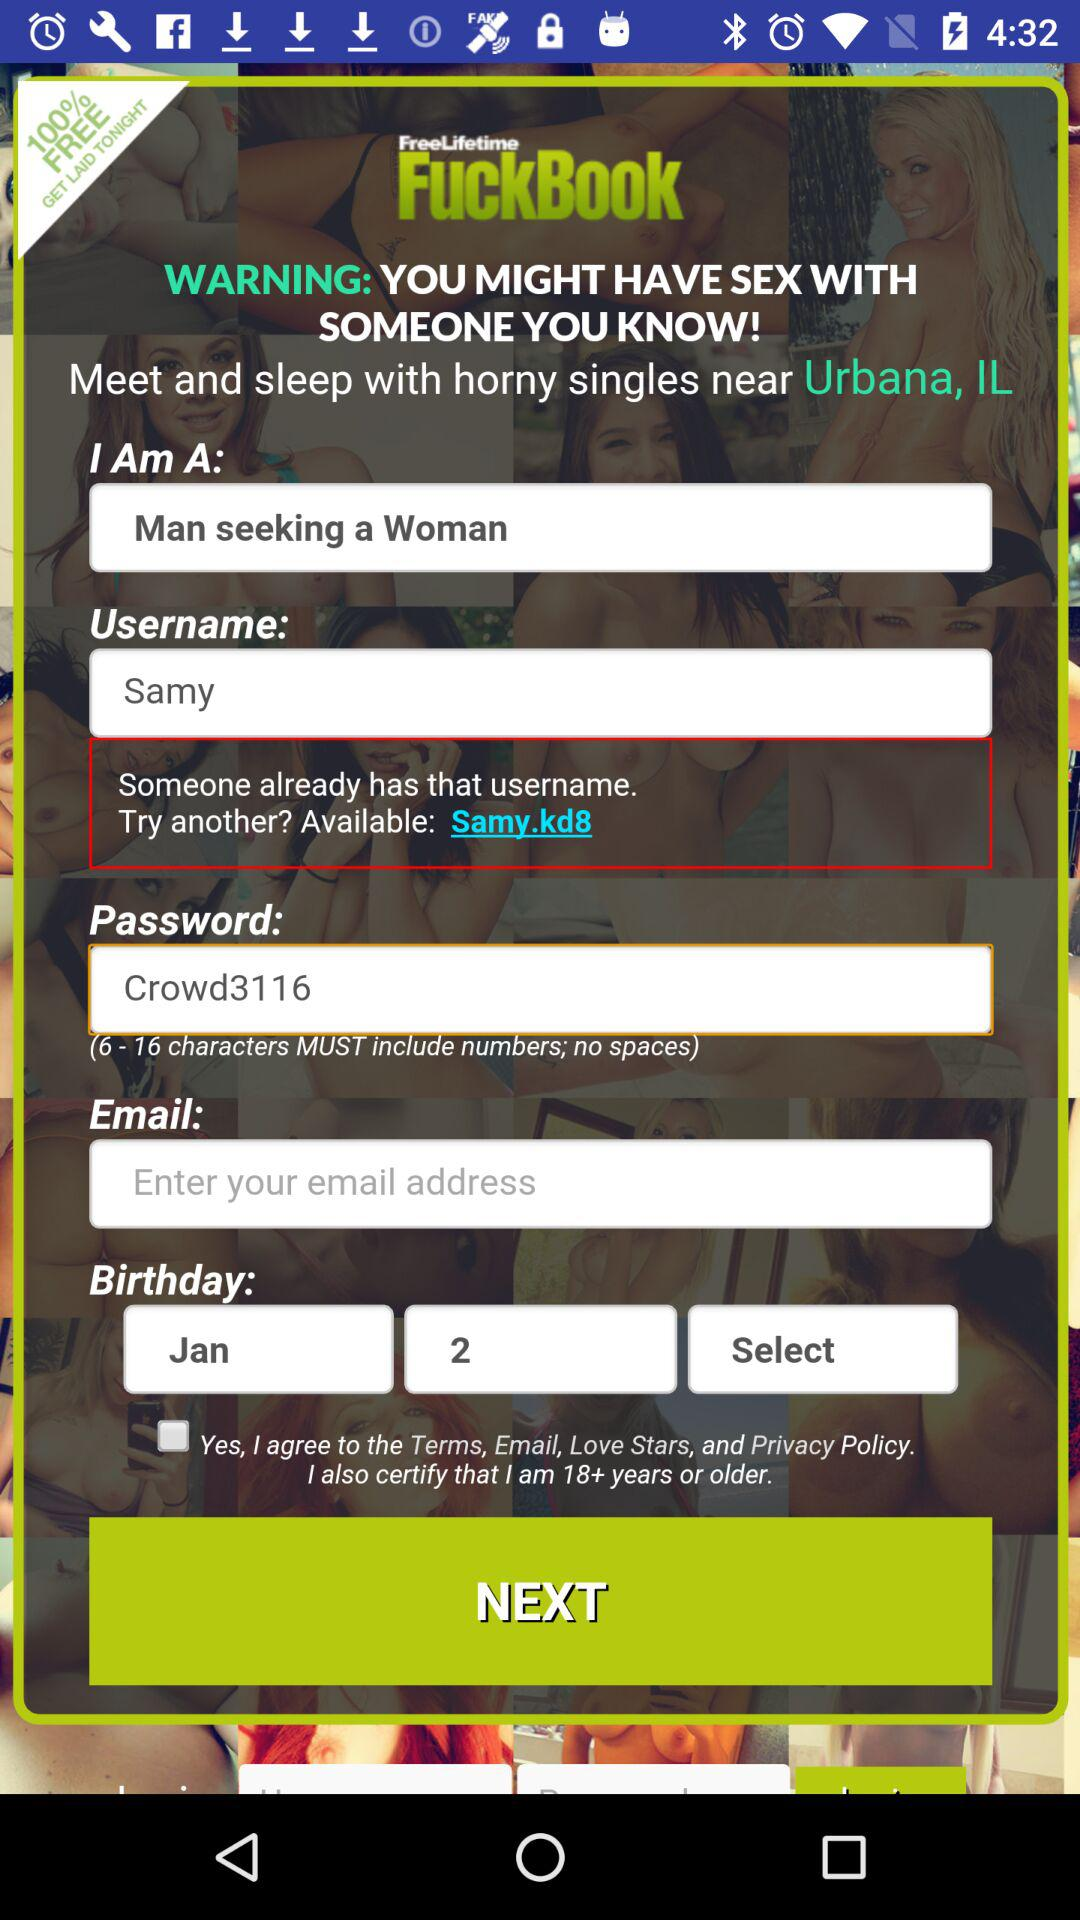What is the mentioned location? The mentioned location is Urbana, IL. 